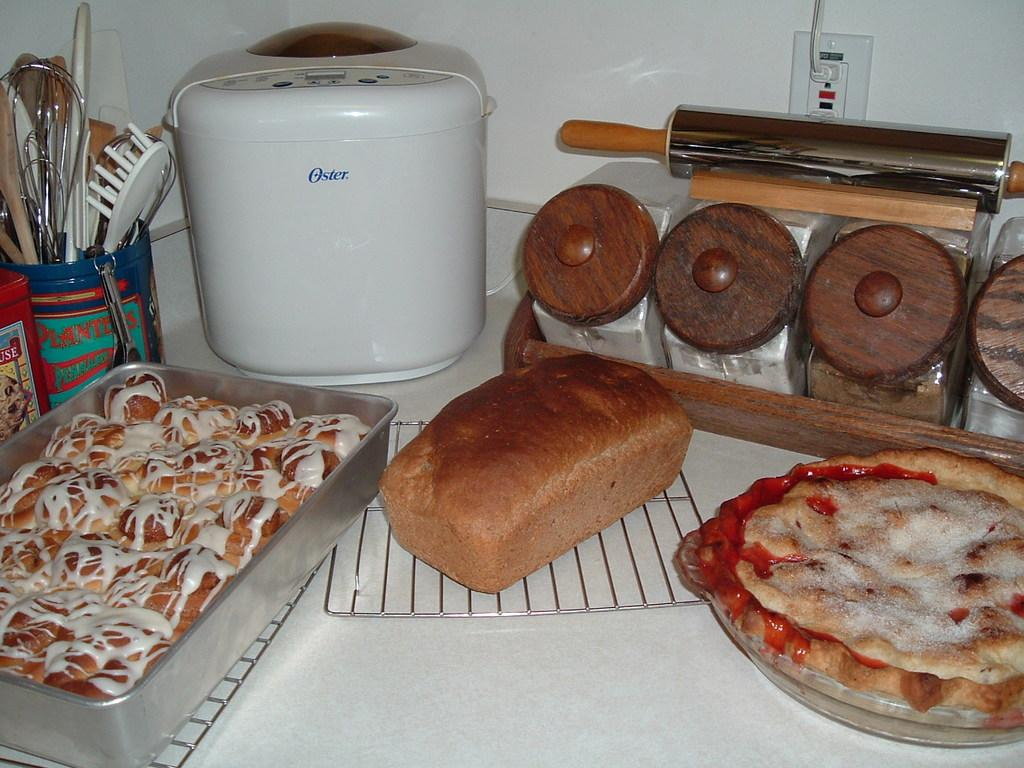<image>
Provide a brief description of the given image. A kitchen full of baked goods and an Oster bread maker 